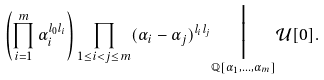Convert formula to latex. <formula><loc_0><loc_0><loc_500><loc_500>\left ( \prod _ { i = 1 } ^ { m } \alpha _ { i } ^ { l _ { 0 } l _ { i } } \right ) \prod _ { 1 \leq i < j \leq m } ( \alpha _ { i } - \alpha _ { j } ) ^ { l _ { i } l _ { j } } \underset { \mathbb { Q } [ \alpha _ { 1 } , \dots , \alpha _ { m } ] } { \Big | } \mathcal { U } [ 0 ] .</formula> 